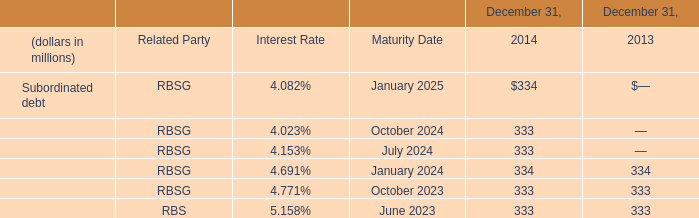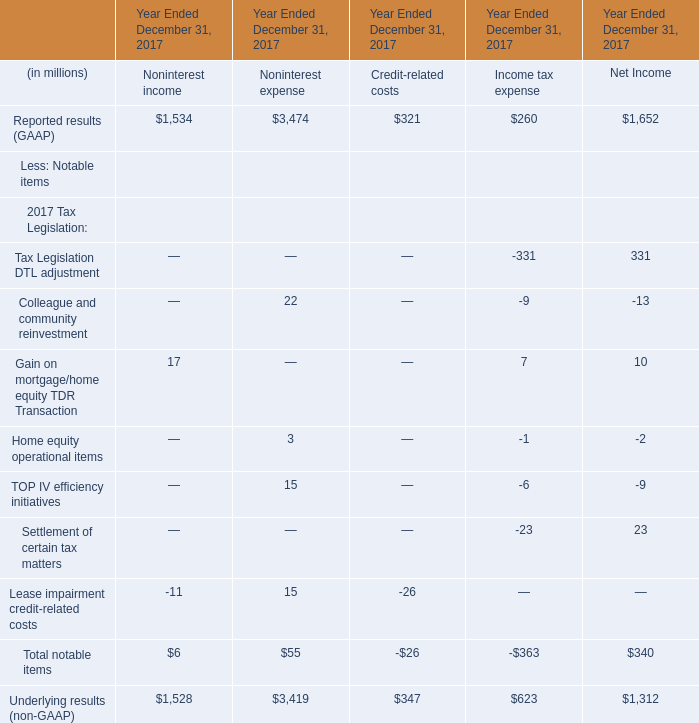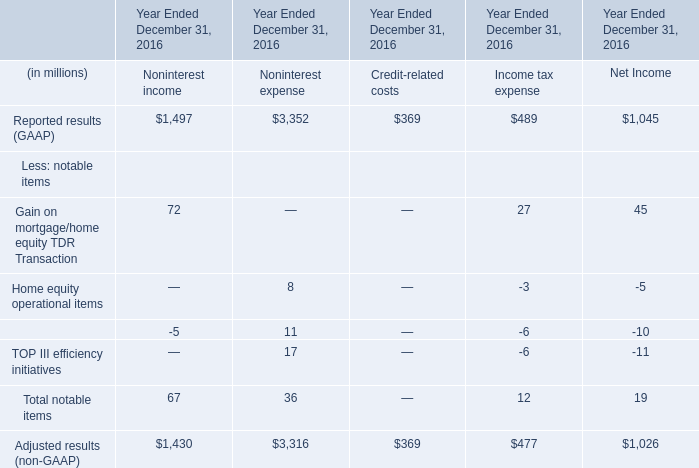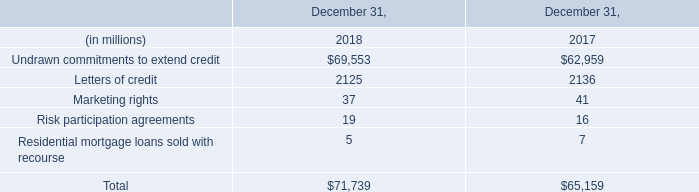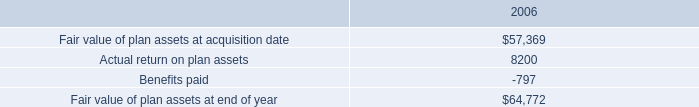what is the total cash spent for the repurchase of shares during 2006 , ( in millions ) ? 
Computations: ((4261200 * 37.60) / 1000000)
Answer: 160.22112. 